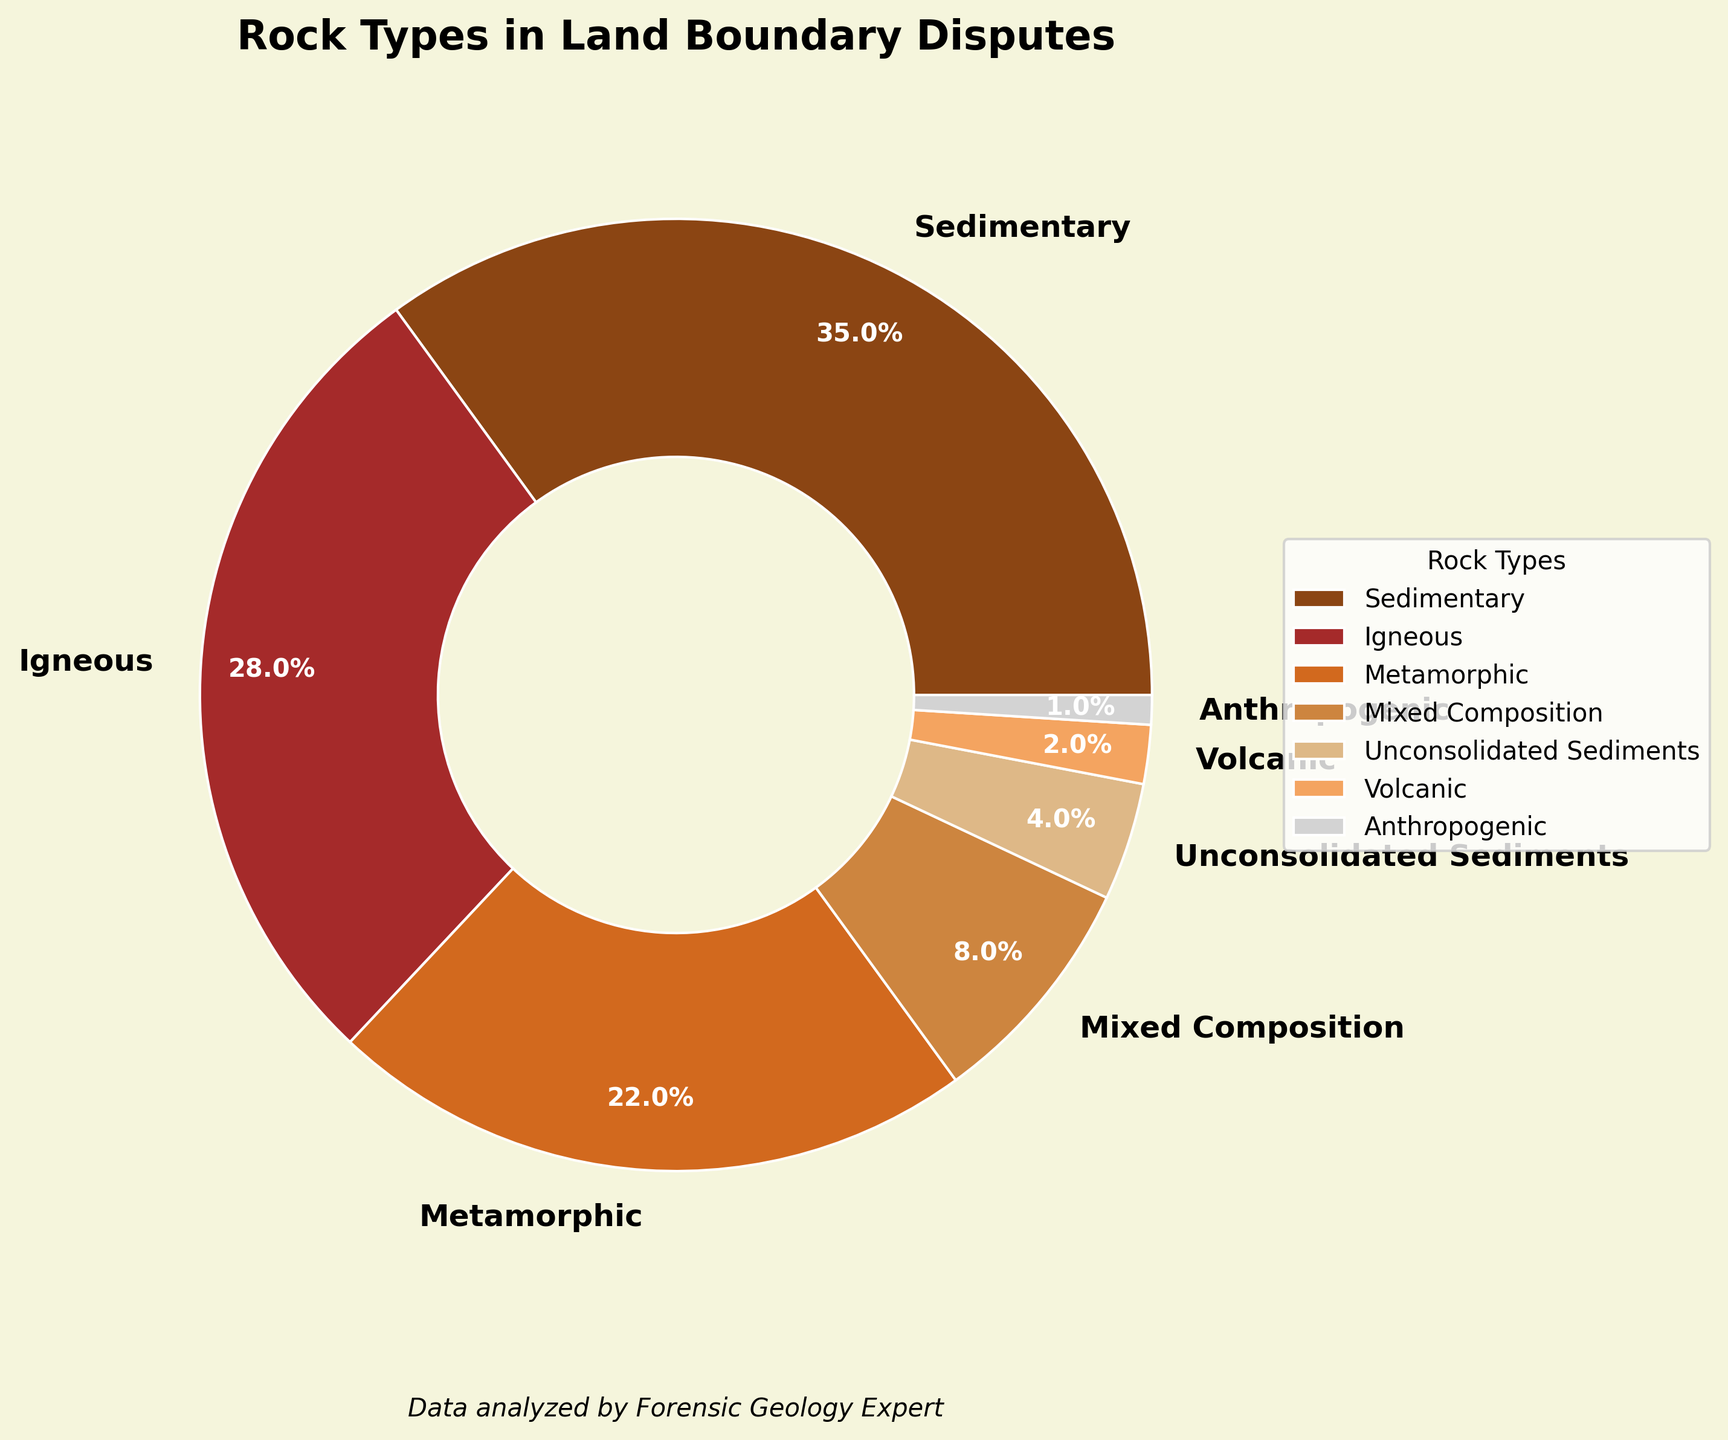What's the total percentage of sedimentary and igneous rocks combined? The percentages for sedimentary and igneous rocks are 35% and 28% respectively. Summing them up gives 35 + 28 = 63%.
Answer: 63% Which rock type constitutes the smallest percentage in land boundary disputes? Observing the pie chart, the anthropogenic rock type constitutes the smallest percentage at 1%.
Answer: Anthropogenic How many rock types together make up 50% or more of the land boundary disputes? Adding the percentages from the largest to smallest, we see that Sedimentary (35%), Igneous (28%), and Metamorphic (22%) rock types together total 85%, which is more than 50%.
Answer: 3 Is the percentage of sedimentary rocks greater than the combined percentage of volcanic and unconsolidated sediments? Sedimentary rocks constitute 35%. The combined percentage for volcanic and unconsolidated sediments is 2% + 4% = 6%. Since 35% is greater than 6%, the percentage of sedimentary rocks is indeed greater.
Answer: Yes How much greater is the percentage of metamorphic rocks compared to volcanic rocks? Metamorphic rocks constitute 22%, and volcanic rocks constitute 2%. The difference is 22% - 2% = 20%.
Answer: 20% Which colored segment represents the mixed composition rock type and what is its percentage? The mixed composition segment is colored differently from sedimentary, igneous, and metamorphic sections. It is represented by a unique shade (e.g., a specific brownish color) and constitutes 8%.
Answer: 8% What is the sum of the percentages of all rock types other than sedimentary and igneous? The percentages for metamorphic, mixed composition, unconsolidated sediments, volcanic, and anthropogenic are 22%, 8%, 4%, 2%, and 1%, respectively. Summing them up: 22 + 8 + 4 + 2 + 1 = 37%.
Answer: 37% Are sedimentary rocks more prevalent than all other types of rocks combined? Sedimentary rocks constitute 35%. The combined percentage for all other types is 100% - 35% = 65%, which is higher than 35%. Thus, sedimentary rocks are not more prevalent.
Answer: No What is the color of the segment representing unconsolidated sediments and what size is it relative to volcanic rocks? The segment for unconsolidated sediments is identified by its specific color (e.g., light brown) and it constitutes 4%, which is twice as much as the percentage for volcanic rocks (2%).
Answer: 4% Identify the second largest rock type by percentage and its percentage. The second largest percentage is represented by igneous rocks which constitute 28%.
Answer: Igneous, 28% 